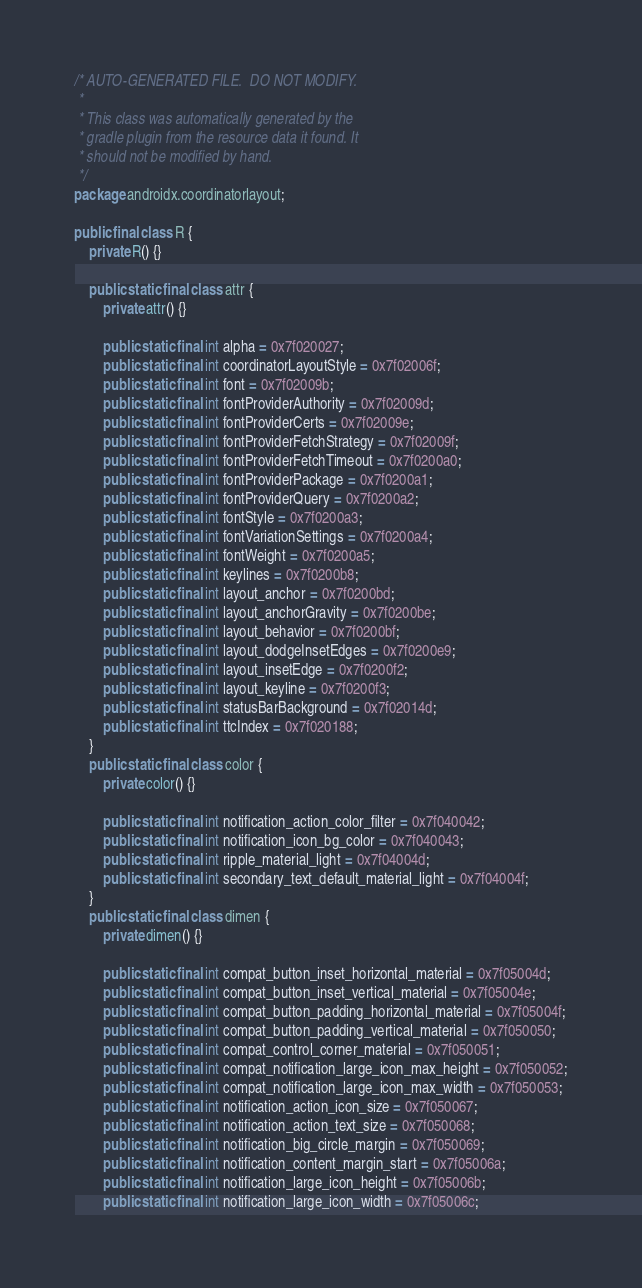Convert code to text. <code><loc_0><loc_0><loc_500><loc_500><_Java_>/* AUTO-GENERATED FILE.  DO NOT MODIFY.
 *
 * This class was automatically generated by the
 * gradle plugin from the resource data it found. It
 * should not be modified by hand.
 */
package androidx.coordinatorlayout;

public final class R {
    private R() {}

    public static final class attr {
        private attr() {}

        public static final int alpha = 0x7f020027;
        public static final int coordinatorLayoutStyle = 0x7f02006f;
        public static final int font = 0x7f02009b;
        public static final int fontProviderAuthority = 0x7f02009d;
        public static final int fontProviderCerts = 0x7f02009e;
        public static final int fontProviderFetchStrategy = 0x7f02009f;
        public static final int fontProviderFetchTimeout = 0x7f0200a0;
        public static final int fontProviderPackage = 0x7f0200a1;
        public static final int fontProviderQuery = 0x7f0200a2;
        public static final int fontStyle = 0x7f0200a3;
        public static final int fontVariationSettings = 0x7f0200a4;
        public static final int fontWeight = 0x7f0200a5;
        public static final int keylines = 0x7f0200b8;
        public static final int layout_anchor = 0x7f0200bd;
        public static final int layout_anchorGravity = 0x7f0200be;
        public static final int layout_behavior = 0x7f0200bf;
        public static final int layout_dodgeInsetEdges = 0x7f0200e9;
        public static final int layout_insetEdge = 0x7f0200f2;
        public static final int layout_keyline = 0x7f0200f3;
        public static final int statusBarBackground = 0x7f02014d;
        public static final int ttcIndex = 0x7f020188;
    }
    public static final class color {
        private color() {}

        public static final int notification_action_color_filter = 0x7f040042;
        public static final int notification_icon_bg_color = 0x7f040043;
        public static final int ripple_material_light = 0x7f04004d;
        public static final int secondary_text_default_material_light = 0x7f04004f;
    }
    public static final class dimen {
        private dimen() {}

        public static final int compat_button_inset_horizontal_material = 0x7f05004d;
        public static final int compat_button_inset_vertical_material = 0x7f05004e;
        public static final int compat_button_padding_horizontal_material = 0x7f05004f;
        public static final int compat_button_padding_vertical_material = 0x7f050050;
        public static final int compat_control_corner_material = 0x7f050051;
        public static final int compat_notification_large_icon_max_height = 0x7f050052;
        public static final int compat_notification_large_icon_max_width = 0x7f050053;
        public static final int notification_action_icon_size = 0x7f050067;
        public static final int notification_action_text_size = 0x7f050068;
        public static final int notification_big_circle_margin = 0x7f050069;
        public static final int notification_content_margin_start = 0x7f05006a;
        public static final int notification_large_icon_height = 0x7f05006b;
        public static final int notification_large_icon_width = 0x7f05006c;</code> 